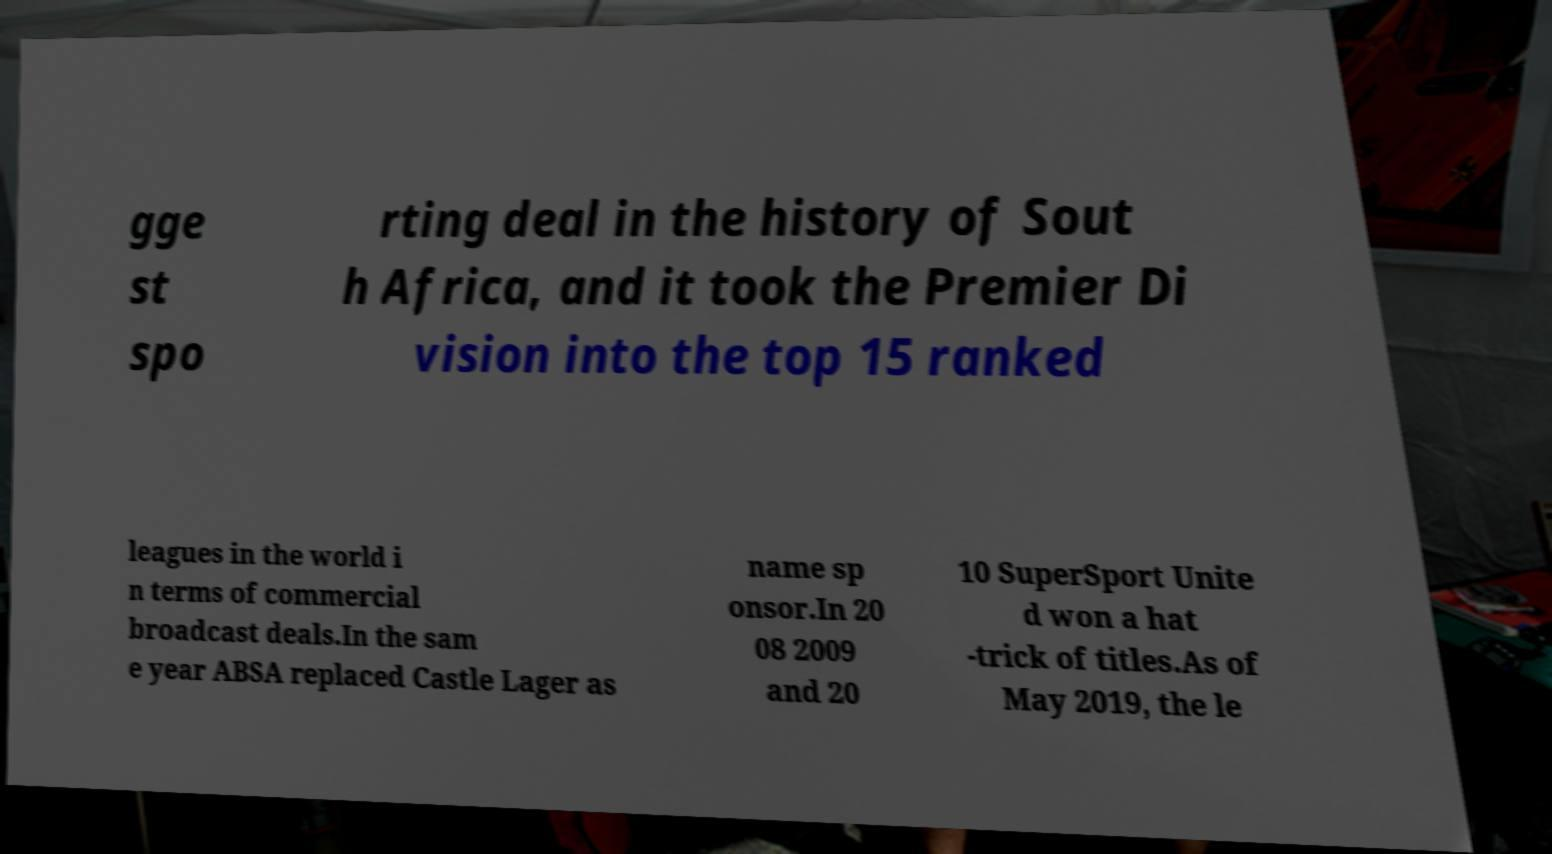What messages or text are displayed in this image? I need them in a readable, typed format. gge st spo rting deal in the history of Sout h Africa, and it took the Premier Di vision into the top 15 ranked leagues in the world i n terms of commercial broadcast deals.In the sam e year ABSA replaced Castle Lager as name sp onsor.In 20 08 2009 and 20 10 SuperSport Unite d won a hat -trick of titles.As of May 2019, the le 